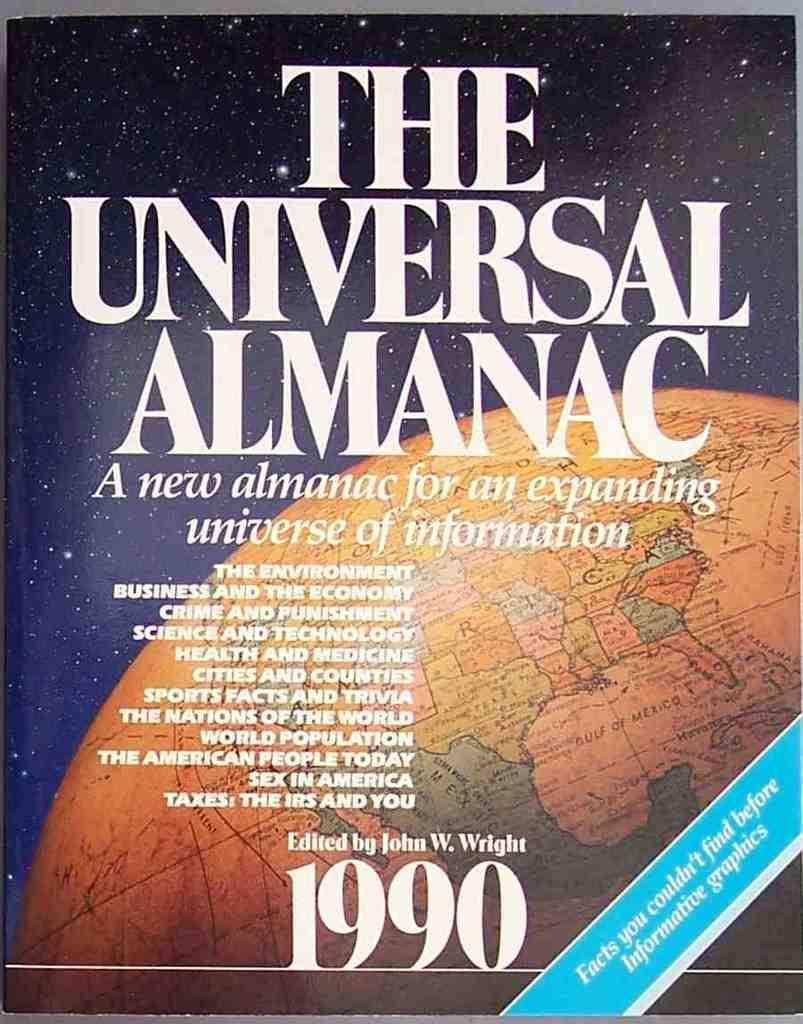Provide a one-sentence caption for the provided image. The cover of The Universal Almanac from 1990. 